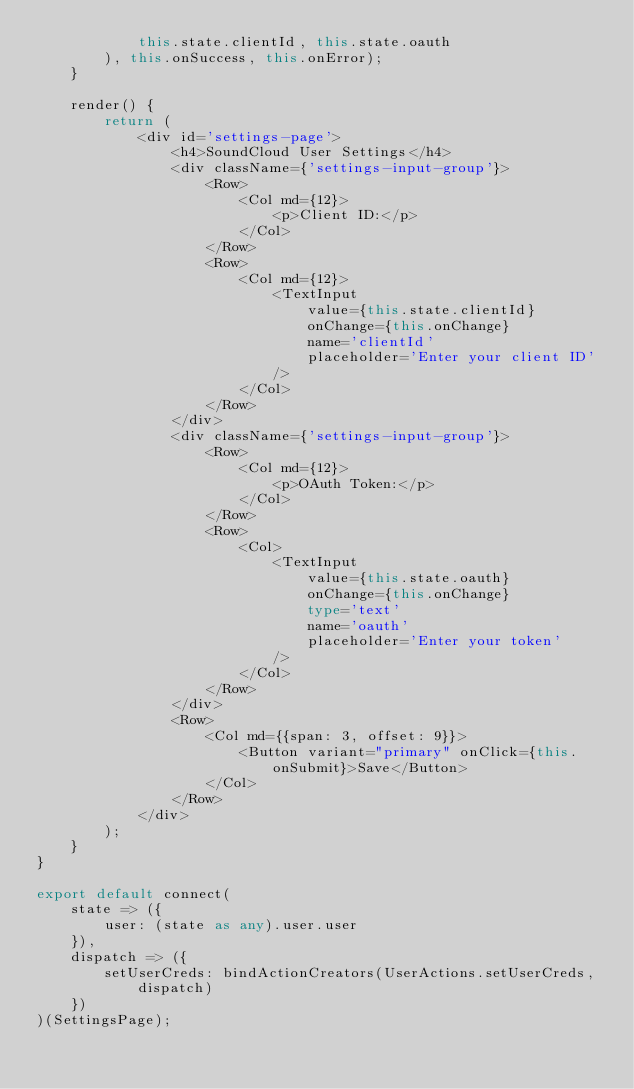Convert code to text. <code><loc_0><loc_0><loc_500><loc_500><_TypeScript_>            this.state.clientId, this.state.oauth
        ), this.onSuccess, this.onError);
    }

    render() {
        return (
            <div id='settings-page'>
                <h4>SoundCloud User Settings</h4>
                <div className={'settings-input-group'}>
                    <Row>
                        <Col md={12}>
                            <p>Client ID:</p>
                        </Col>
                    </Row>
                    <Row>
                        <Col md={12}>
                            <TextInput
                                value={this.state.clientId}
                                onChange={this.onChange}
                                name='clientId'
                                placeholder='Enter your client ID'
                            />
                        </Col>
                    </Row>
                </div>
                <div className={'settings-input-group'}>
                    <Row>
                        <Col md={12}>
                            <p>OAuth Token:</p>
                        </Col>
                    </Row>
                    <Row>
                        <Col>
                            <TextInput
                                value={this.state.oauth}
                                onChange={this.onChange}
                                type='text'
                                name='oauth'
                                placeholder='Enter your token'
                            />
                        </Col>
                    </Row>
                </div>
                <Row>
                    <Col md={{span: 3, offset: 9}}>
                        <Button variant="primary" onClick={this.onSubmit}>Save</Button>
                    </Col>
                </Row>
            </div>
        );
    }
}

export default connect(
    state => ({
        user: (state as any).user.user
    }),
    dispatch => ({
        setUserCreds: bindActionCreators(UserActions.setUserCreds, dispatch)
    })
)(SettingsPage);
</code> 